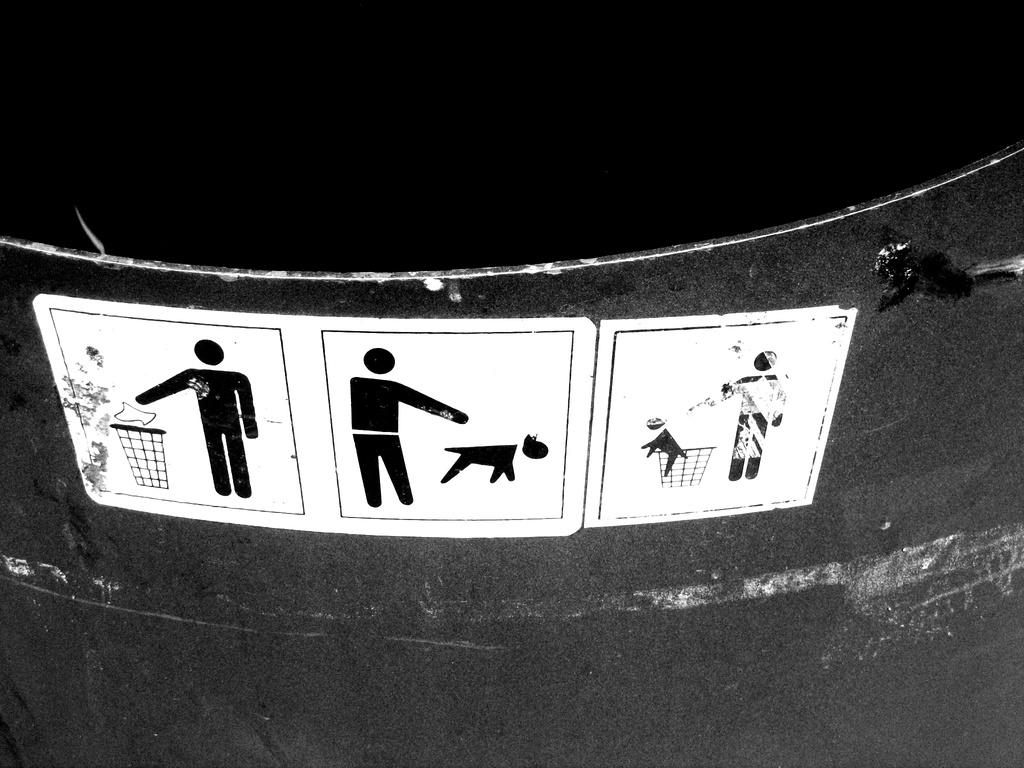What object is present in the image that is typically used for waste disposal? There is a dustbin in the image. What is unique about the dustbin in the image? The dustbin has animated posters on it. What degree does the father in the image hold? There is no father present in the image, and therefore no degree can be attributed to him. 